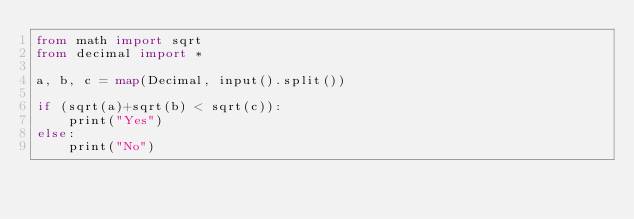<code> <loc_0><loc_0><loc_500><loc_500><_Nim_>from math import sqrt
from decimal import *

a, b, c = map(Decimal, input().split())

if (sqrt(a)+sqrt(b) < sqrt(c)):
    print("Yes")
else:
    print("No")</code> 